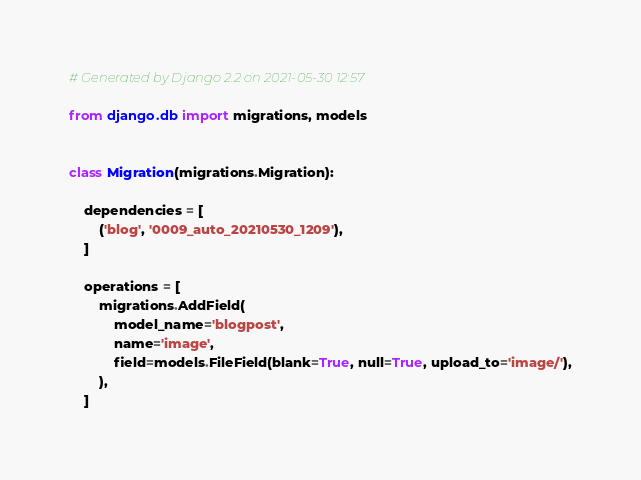<code> <loc_0><loc_0><loc_500><loc_500><_Python_># Generated by Django 2.2 on 2021-05-30 12:57

from django.db import migrations, models


class Migration(migrations.Migration):

    dependencies = [
        ('blog', '0009_auto_20210530_1209'),
    ]

    operations = [
        migrations.AddField(
            model_name='blogpost',
            name='image',
            field=models.FileField(blank=True, null=True, upload_to='image/'),
        ),
    ]
</code> 